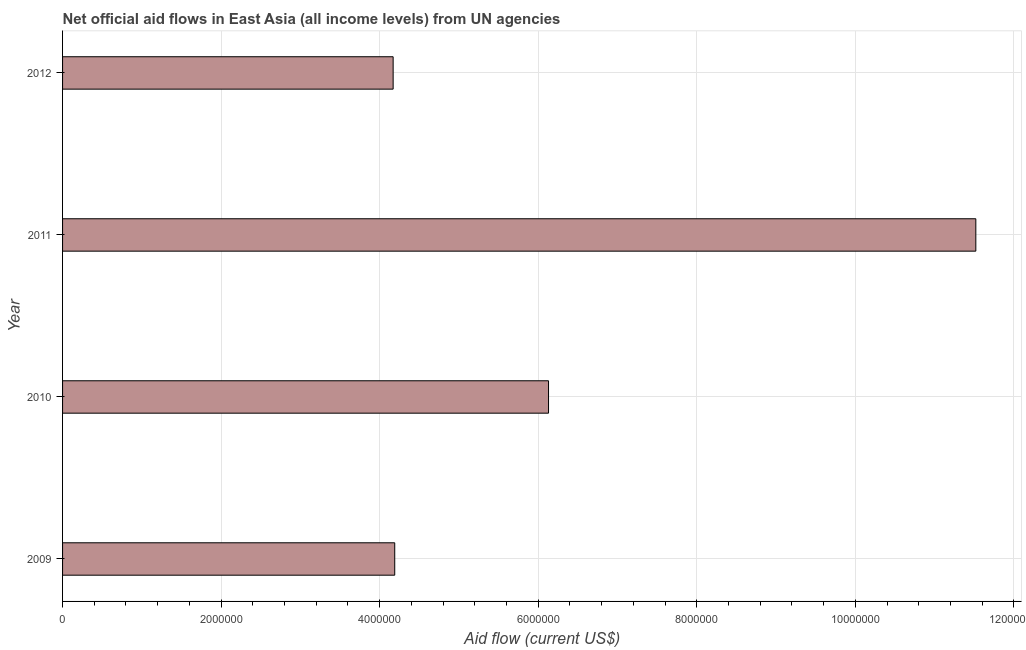Does the graph contain any zero values?
Ensure brevity in your answer.  No. Does the graph contain grids?
Offer a terse response. Yes. What is the title of the graph?
Provide a succinct answer. Net official aid flows in East Asia (all income levels) from UN agencies. What is the label or title of the Y-axis?
Offer a very short reply. Year. What is the net official flows from un agencies in 2010?
Offer a very short reply. 6.13e+06. Across all years, what is the maximum net official flows from un agencies?
Your answer should be very brief. 1.15e+07. Across all years, what is the minimum net official flows from un agencies?
Ensure brevity in your answer.  4.17e+06. In which year was the net official flows from un agencies minimum?
Give a very brief answer. 2012. What is the sum of the net official flows from un agencies?
Your answer should be very brief. 2.60e+07. What is the difference between the net official flows from un agencies in 2010 and 2012?
Your answer should be very brief. 1.96e+06. What is the average net official flows from un agencies per year?
Ensure brevity in your answer.  6.50e+06. What is the median net official flows from un agencies?
Offer a terse response. 5.16e+06. In how many years, is the net official flows from un agencies greater than 4000000 US$?
Your response must be concise. 4. What is the ratio of the net official flows from un agencies in 2009 to that in 2010?
Offer a terse response. 0.68. What is the difference between the highest and the second highest net official flows from un agencies?
Offer a terse response. 5.39e+06. Is the sum of the net official flows from un agencies in 2009 and 2011 greater than the maximum net official flows from un agencies across all years?
Offer a terse response. Yes. What is the difference between the highest and the lowest net official flows from un agencies?
Your response must be concise. 7.35e+06. In how many years, is the net official flows from un agencies greater than the average net official flows from un agencies taken over all years?
Provide a succinct answer. 1. How many bars are there?
Your answer should be compact. 4. Are all the bars in the graph horizontal?
Offer a terse response. Yes. What is the difference between two consecutive major ticks on the X-axis?
Your response must be concise. 2.00e+06. Are the values on the major ticks of X-axis written in scientific E-notation?
Ensure brevity in your answer.  No. What is the Aid flow (current US$) of 2009?
Keep it short and to the point. 4.19e+06. What is the Aid flow (current US$) of 2010?
Your answer should be very brief. 6.13e+06. What is the Aid flow (current US$) of 2011?
Offer a terse response. 1.15e+07. What is the Aid flow (current US$) in 2012?
Offer a very short reply. 4.17e+06. What is the difference between the Aid flow (current US$) in 2009 and 2010?
Your answer should be very brief. -1.94e+06. What is the difference between the Aid flow (current US$) in 2009 and 2011?
Keep it short and to the point. -7.33e+06. What is the difference between the Aid flow (current US$) in 2010 and 2011?
Provide a succinct answer. -5.39e+06. What is the difference between the Aid flow (current US$) in 2010 and 2012?
Your answer should be very brief. 1.96e+06. What is the difference between the Aid flow (current US$) in 2011 and 2012?
Your answer should be compact. 7.35e+06. What is the ratio of the Aid flow (current US$) in 2009 to that in 2010?
Give a very brief answer. 0.68. What is the ratio of the Aid flow (current US$) in 2009 to that in 2011?
Provide a short and direct response. 0.36. What is the ratio of the Aid flow (current US$) in 2009 to that in 2012?
Your answer should be compact. 1. What is the ratio of the Aid flow (current US$) in 2010 to that in 2011?
Provide a short and direct response. 0.53. What is the ratio of the Aid flow (current US$) in 2010 to that in 2012?
Give a very brief answer. 1.47. What is the ratio of the Aid flow (current US$) in 2011 to that in 2012?
Your answer should be compact. 2.76. 